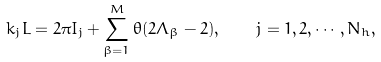Convert formula to latex. <formula><loc_0><loc_0><loc_500><loc_500>k _ { j } L = 2 \pi I _ { j } + \sum ^ { M } _ { \beta = 1 } \theta ( 2 \Lambda _ { \beta } - 2 ) , \quad j = 1 , 2 , \cdots , N _ { h } ,</formula> 